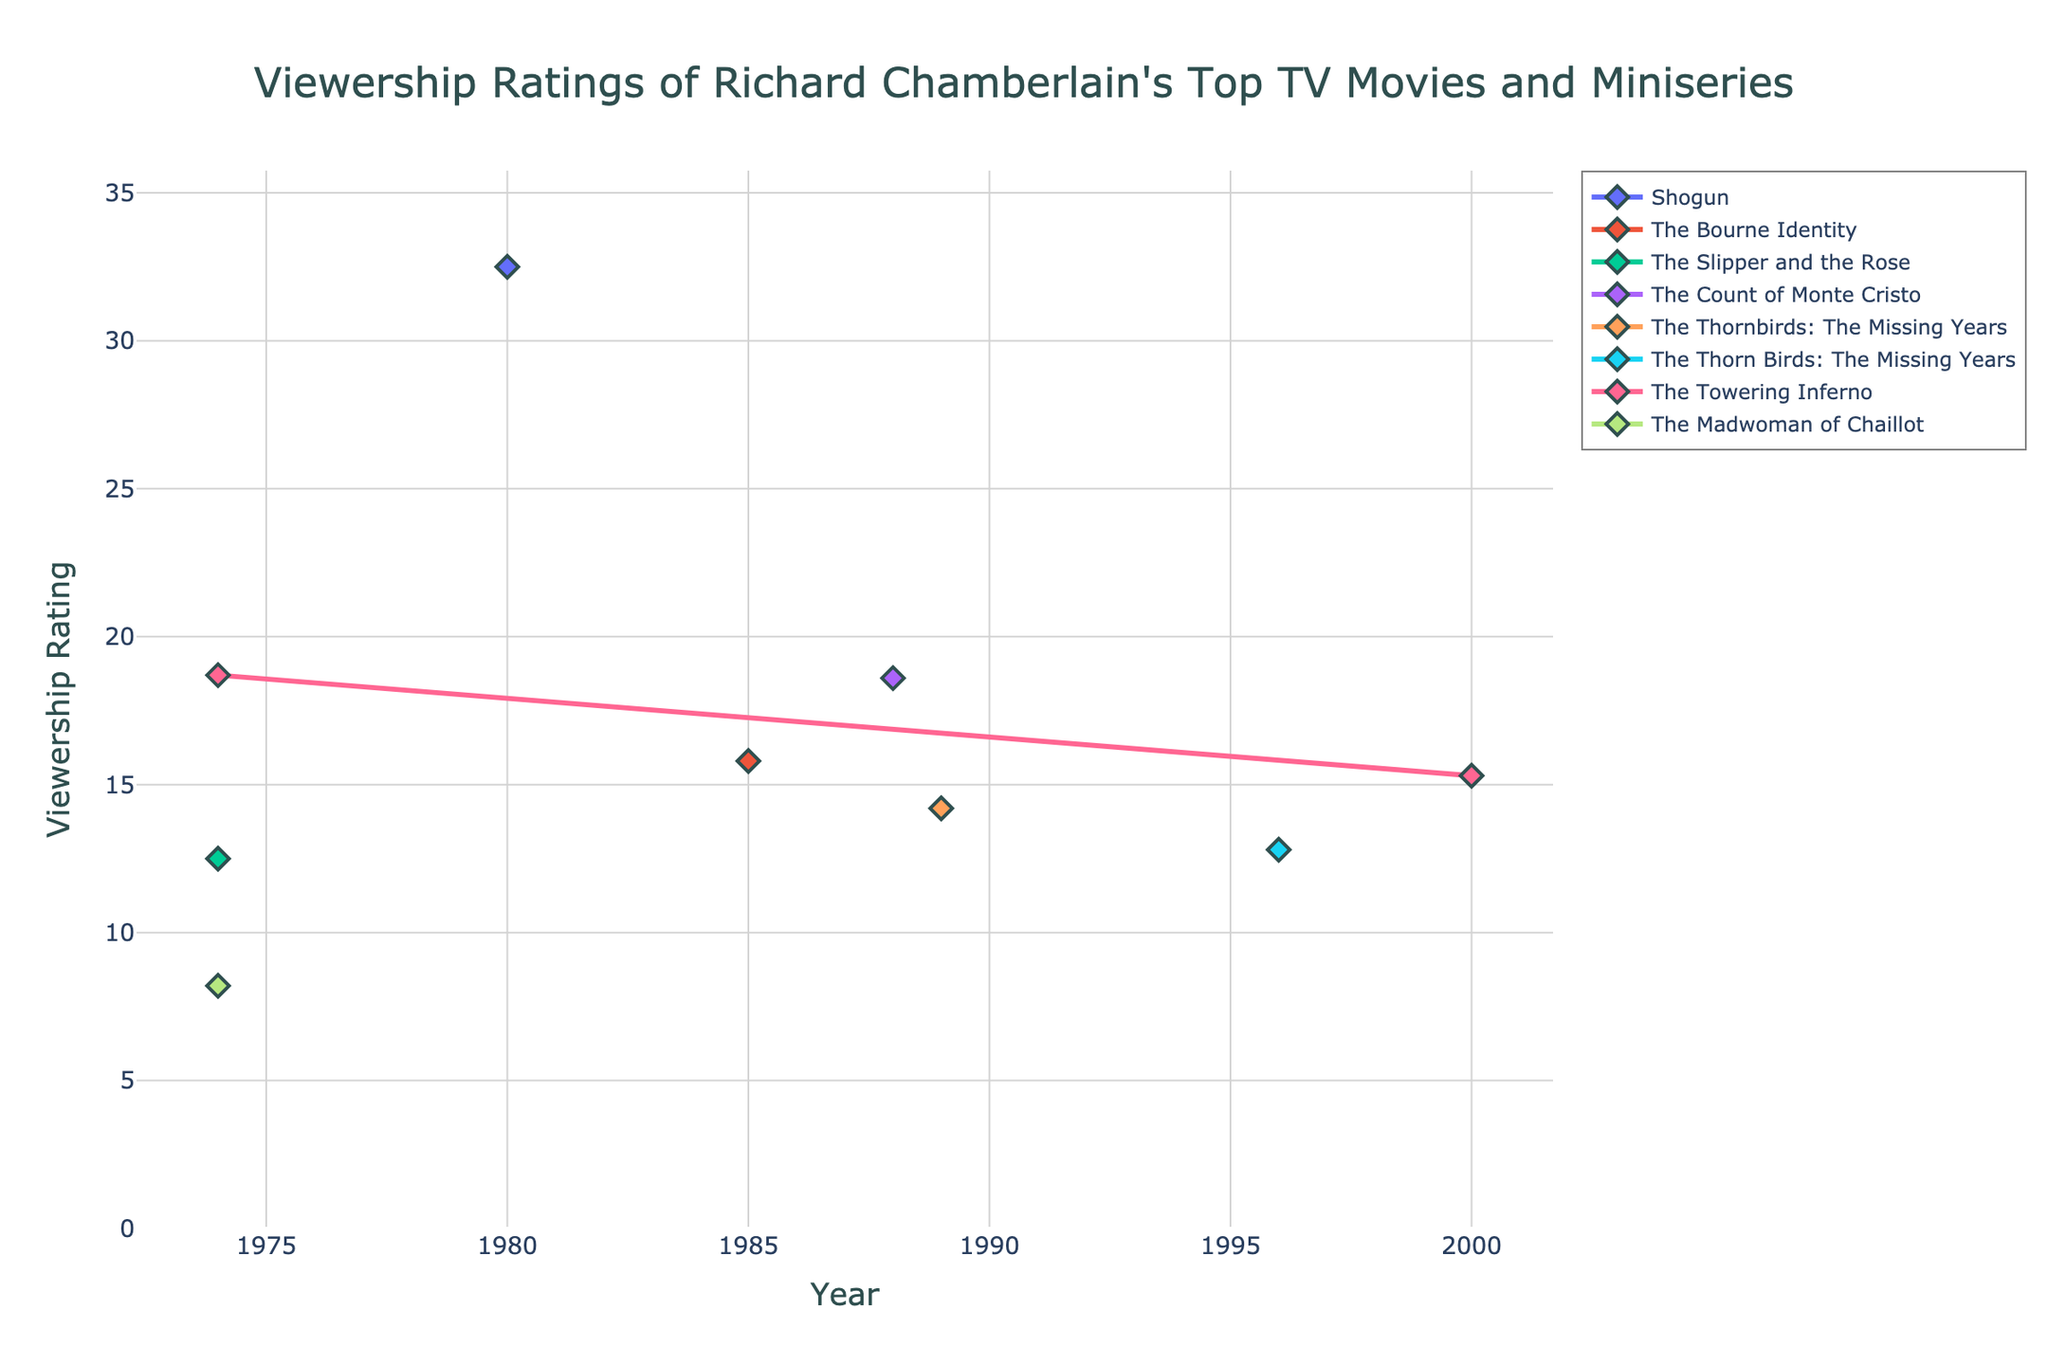What year had the highest viewership rating for "Shogun"? The plot shows the viewership ratings over the years for each movie. By examining the line for "Shogun," we see it peaks in 1980 at 32.5.
Answer: 1980 Which movie had the highest viewership rating in 1988? By looking at the viewership ratings for each movie in 1988, we can see that "The Count of Monte Cristo" had the highest viewership rating.
Answer: The Count of Monte Cristo Between "The Thorn Birds" and "The Bourne Identity," which movie had a higher viewership rating, and what is the difference between their highest ratings? The plot shows "The Thorn Birds" ratings in 1983 and "The Bourne Identity" in 1985. Comparing these, "The Thorn Birds" has a higher viewership at 32.5 compared to 15.8 for "The Bourne Identity." The difference is 32.5 - 15.8 = 16.7.
Answer: "The Thorn Birds," 16.7 In which year did "The Towering Inferno" achieve its highest viewership rating? Refer to the plot for the viewership ratings of "The Towering Inferno." It only has data for 1974 and its rating is 18.7, so 1974 is the year with its highest viewership rating.
Answer: 1974 Compare the viewership ratings for "The Madwoman of Chaillot" and "The Slipper and the Rose" in their respective best years. Which one had a higher rating? "The Madwoman of Chaillot" rating in 2000 is 15.3. "The Slipper and the Rose" had a higher viewership in 1976 with 12.5. Comparing these, "The Madwoman of Chaillot" had a higher rating with 15.3.
Answer: "The Madwoman of Chaillot" What is the average viewership rating of "The Thorn Birds" across all recorded years? "The Thorn Birds" has ratings recorded only in 1980 and 1983 at 25.5. Therefore, the average is simply 25.5 / 1 = 25.5.
Answer: 25.5 Did viewership for "The Thorn Birds: The Missing Years" ever exceed 15? Check the line for "The Thorn Birds: The Missing Years" across all given years and see if it exceeds 15. It does not; the highest is 14.2 in 1996.
Answer: No What is the combined viewership rating of "The Count of Monte Cristo" and "Centennial" in their highest viewership years? The highest rating for "The Count of Monte Cristo" is in 1988 with 18.6, and for "Centennial" in 1978 with 21.4. Summing these gives 18.6 + 21.4 = 40.
Answer: 40 What is the trend of viewership ratings for "The Thorn Birds: The Missing Years"? Observing "The Thorn Birds: The Missing Years," we see ratings for 1996 and 1999, with a decline from 14.2 to 12.8, showing a downward trend.
Answer: Downward trend 